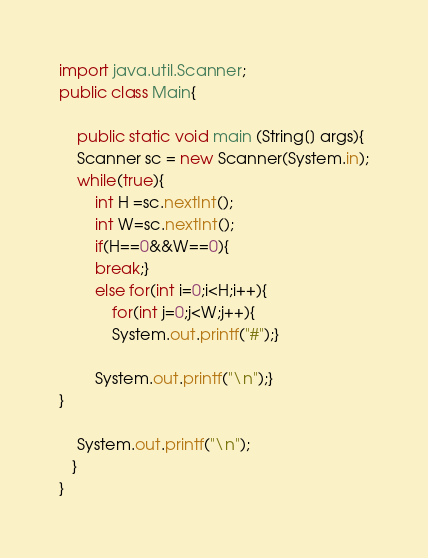<code> <loc_0><loc_0><loc_500><loc_500><_Java_>import java.util.Scanner;
public class Main{ 

    public static void main (String[] args){
	Scanner sc = new Scanner(System.in);
	while(true){
	    int H =sc.nextInt();
	    int W=sc.nextInt();
	    if(H==0&&W==0){
		break;}
	    else for(int i=0;i<H;i++){
		    for(int j=0;j<W;j++){
			System.out.printf("#");}
	
	    System.out.printf("\n");}
}
	    
	System.out.printf("\n");	    	
   }
}</code> 